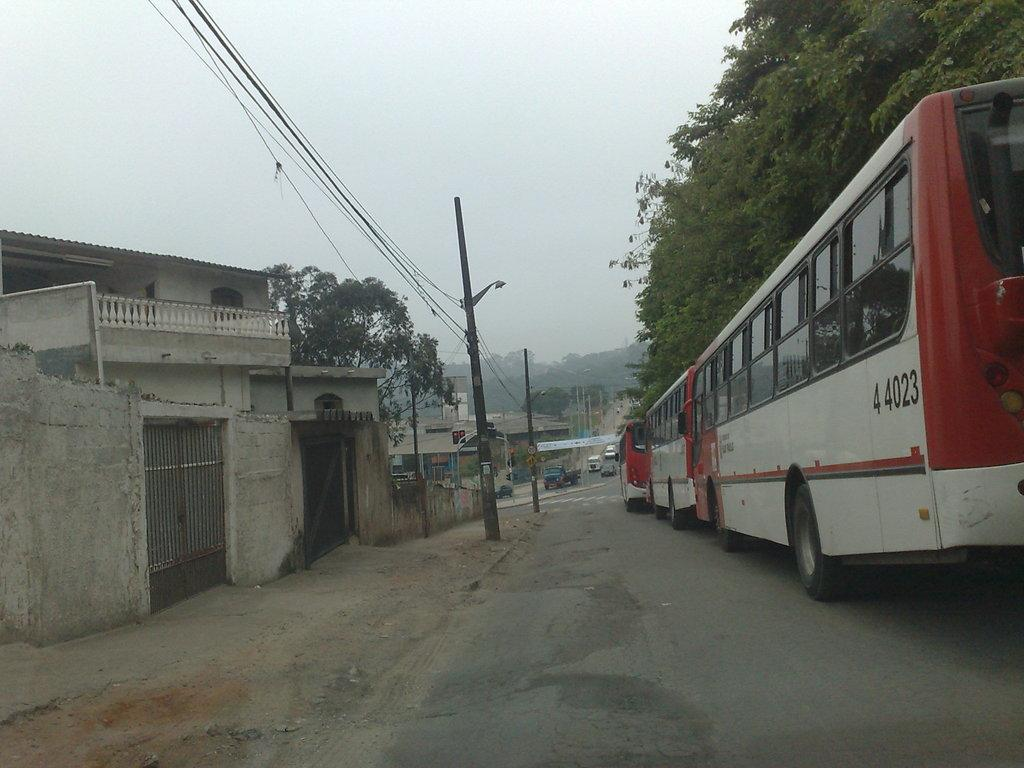What can be seen in the right corner of the image? There are vehicles on the road in the right corner of the image. What is visible in the left corner of the image? There are buildings, poles, and wires in the left corner of the image. What type of vegetation is in the background of the image? There are trees in the background of the image. Can you see a cobweb hanging from the wires in the left corner of the image? There is no cobweb visible in the image; only buildings, poles, and wires are present. Is the road in the right corner of the image covered in fog? There is no mention of fog in the image; the vehicles on the road are visible. 